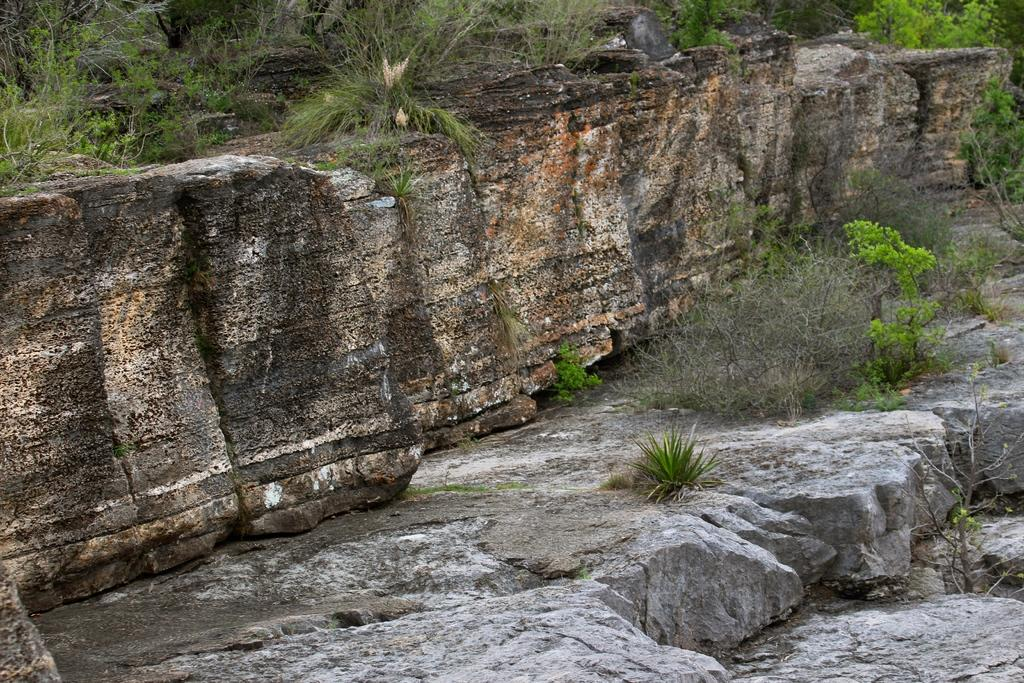What type of structure can be seen in the image? There is a wall in the image. What type of vegetation is present in the image? There are plants and trees in the image. What type of business is being conducted in the image? There is no indication of a business in the image; it primarily features a wall and vegetation. How many pizzas are visible in the image? There are no pizzas present in the image. 